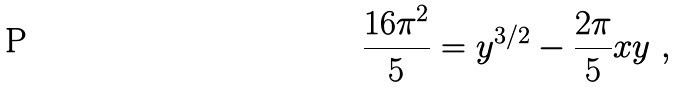Convert formula to latex. <formula><loc_0><loc_0><loc_500><loc_500>\frac { 1 6 \pi ^ { 2 } } { 5 } = y ^ { 3 / 2 } - \frac { 2 \pi } { 5 } x y \ ,</formula> 